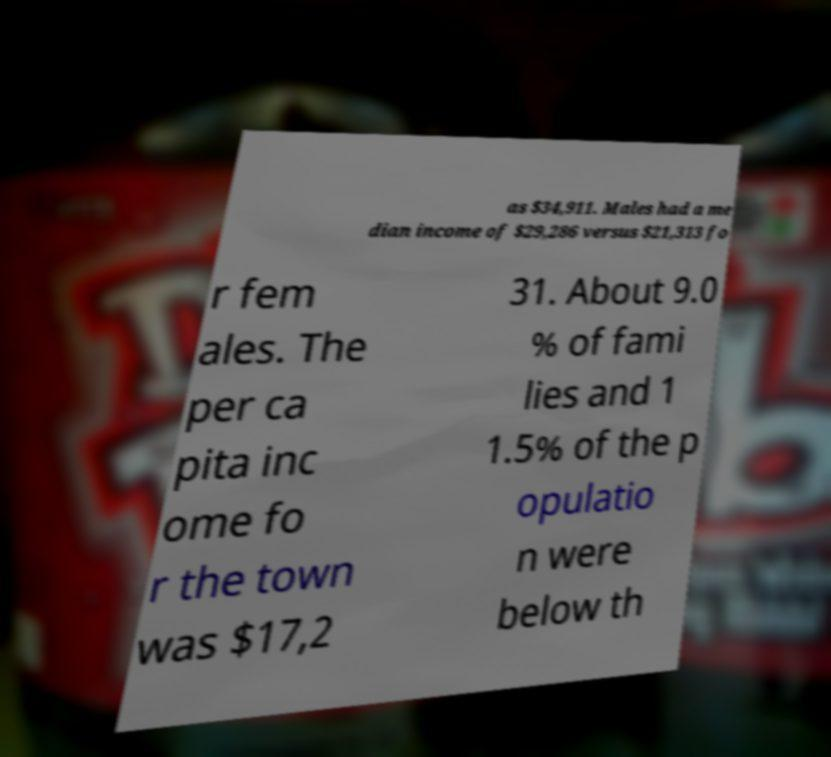I need the written content from this picture converted into text. Can you do that? as $34,911. Males had a me dian income of $29,286 versus $21,313 fo r fem ales. The per ca pita inc ome fo r the town was $17,2 31. About 9.0 % of fami lies and 1 1.5% of the p opulatio n were below th 